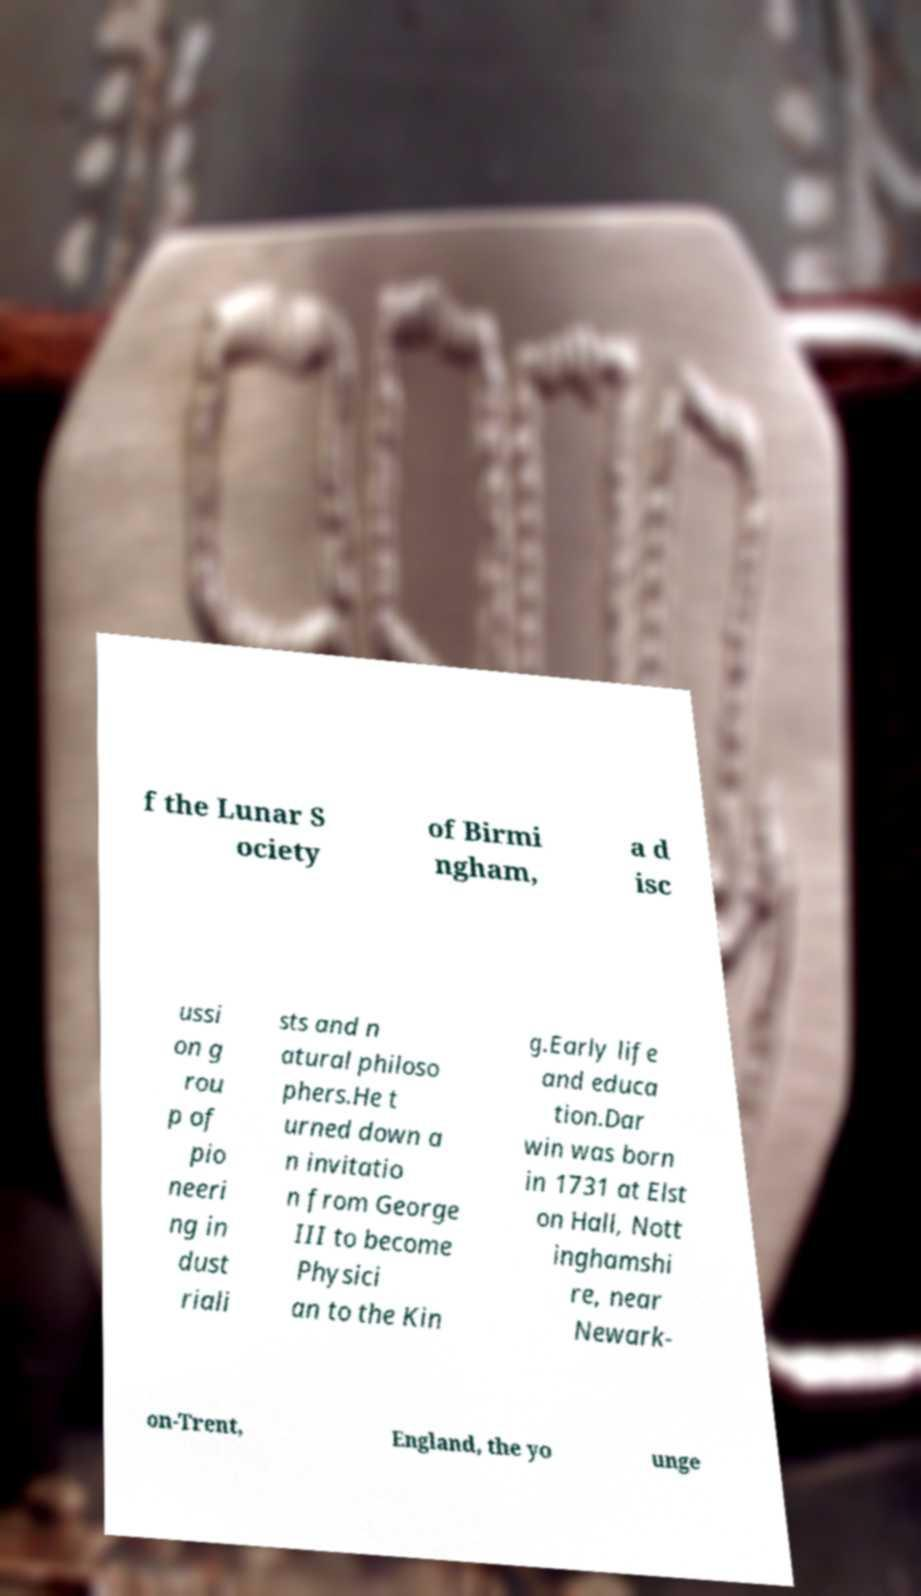What messages or text are displayed in this image? I need them in a readable, typed format. f the Lunar S ociety of Birmi ngham, a d isc ussi on g rou p of pio neeri ng in dust riali sts and n atural philoso phers.He t urned down a n invitatio n from George III to become Physici an to the Kin g.Early life and educa tion.Dar win was born in 1731 at Elst on Hall, Nott inghamshi re, near Newark- on-Trent, England, the yo unge 